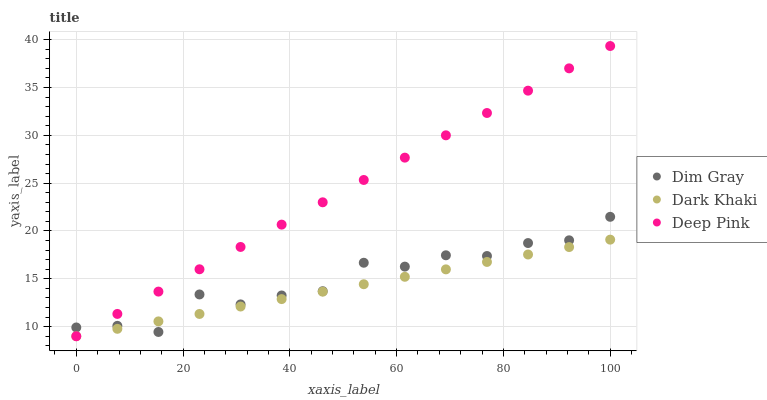Does Dark Khaki have the minimum area under the curve?
Answer yes or no. Yes. Does Deep Pink have the maximum area under the curve?
Answer yes or no. Yes. Does Dim Gray have the minimum area under the curve?
Answer yes or no. No. Does Dim Gray have the maximum area under the curve?
Answer yes or no. No. Is Dark Khaki the smoothest?
Answer yes or no. Yes. Is Dim Gray the roughest?
Answer yes or no. Yes. Is Deep Pink the smoothest?
Answer yes or no. No. Is Deep Pink the roughest?
Answer yes or no. No. Does Dark Khaki have the lowest value?
Answer yes or no. Yes. Does Dim Gray have the lowest value?
Answer yes or no. No. Does Deep Pink have the highest value?
Answer yes or no. Yes. Does Dim Gray have the highest value?
Answer yes or no. No. Does Deep Pink intersect Dim Gray?
Answer yes or no. Yes. Is Deep Pink less than Dim Gray?
Answer yes or no. No. Is Deep Pink greater than Dim Gray?
Answer yes or no. No. 